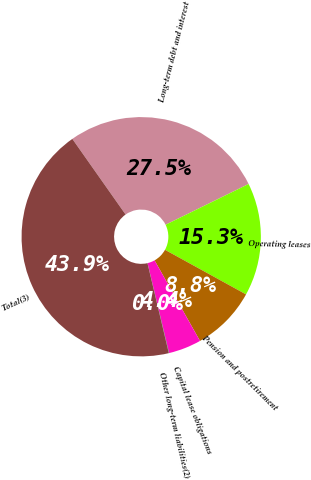<chart> <loc_0><loc_0><loc_500><loc_500><pie_chart><fcel>Long-term debt and interest<fcel>Operating leases<fcel>Pension and postretirement<fcel>Capital lease obligations<fcel>Other long-term liabilities(2)<fcel>Total(3)<nl><fcel>27.5%<fcel>15.27%<fcel>8.82%<fcel>4.43%<fcel>0.04%<fcel>43.94%<nl></chart> 